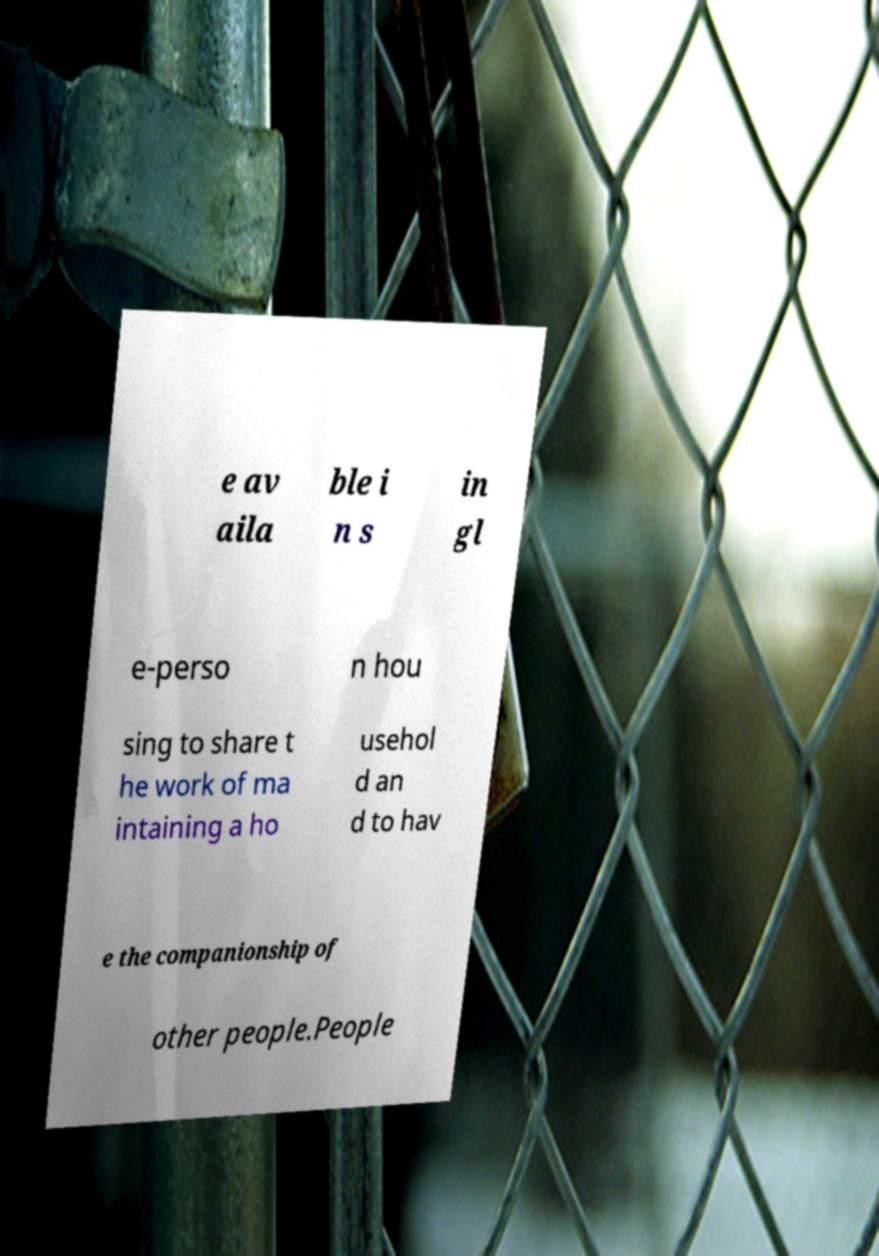There's text embedded in this image that I need extracted. Can you transcribe it verbatim? e av aila ble i n s in gl e-perso n hou sing to share t he work of ma intaining a ho usehol d an d to hav e the companionship of other people.People 